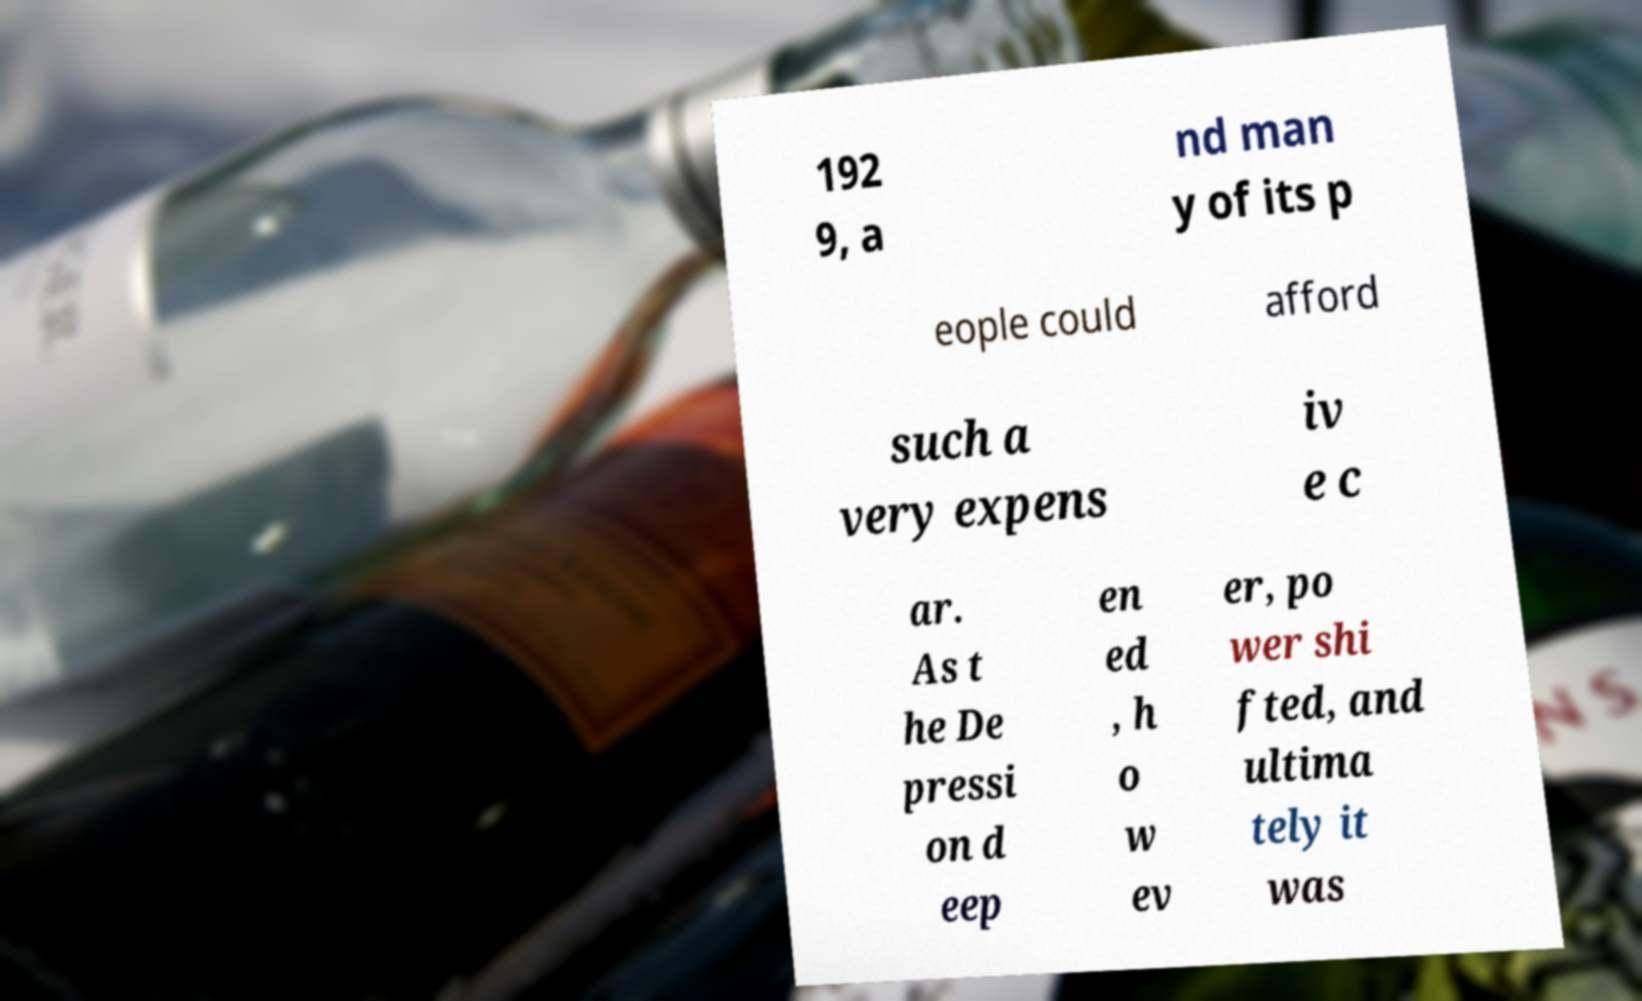Please identify and transcribe the text found in this image. 192 9, a nd man y of its p eople could afford such a very expens iv e c ar. As t he De pressi on d eep en ed , h o w ev er, po wer shi fted, and ultima tely it was 